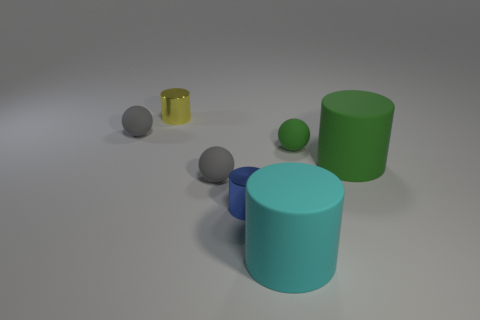Subtract all green cubes. How many gray balls are left? 2 Subtract all cyan cylinders. How many cylinders are left? 3 Subtract all blue cylinders. How many cylinders are left? 3 Add 3 small shiny objects. How many objects exist? 10 Subtract all red cylinders. Subtract all cyan blocks. How many cylinders are left? 4 Subtract all balls. How many objects are left? 4 Add 7 small blue matte cubes. How many small blue matte cubes exist? 7 Subtract 0 purple blocks. How many objects are left? 7 Subtract all big brown rubber blocks. Subtract all blue objects. How many objects are left? 6 Add 5 green cylinders. How many green cylinders are left? 6 